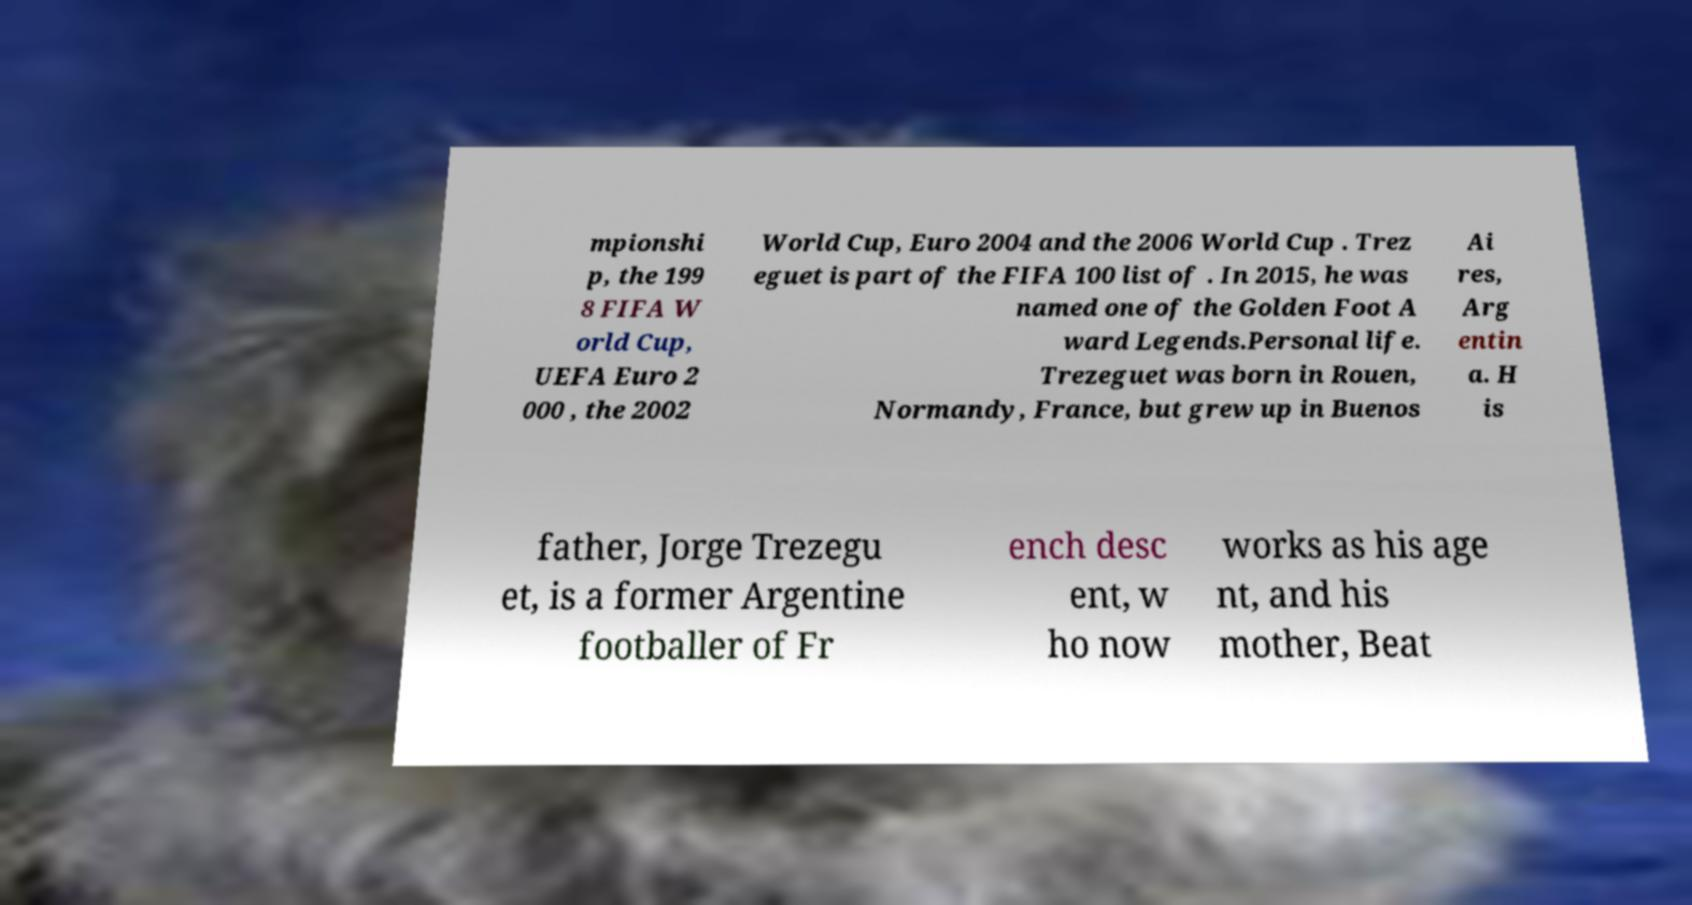What messages or text are displayed in this image? I need them in a readable, typed format. mpionshi p, the 199 8 FIFA W orld Cup, UEFA Euro 2 000 , the 2002 World Cup, Euro 2004 and the 2006 World Cup . Trez eguet is part of the FIFA 100 list of . In 2015, he was named one of the Golden Foot A ward Legends.Personal life. Trezeguet was born in Rouen, Normandy, France, but grew up in Buenos Ai res, Arg entin a. H is father, Jorge Trezegu et, is a former Argentine footballer of Fr ench desc ent, w ho now works as his age nt, and his mother, Beat 